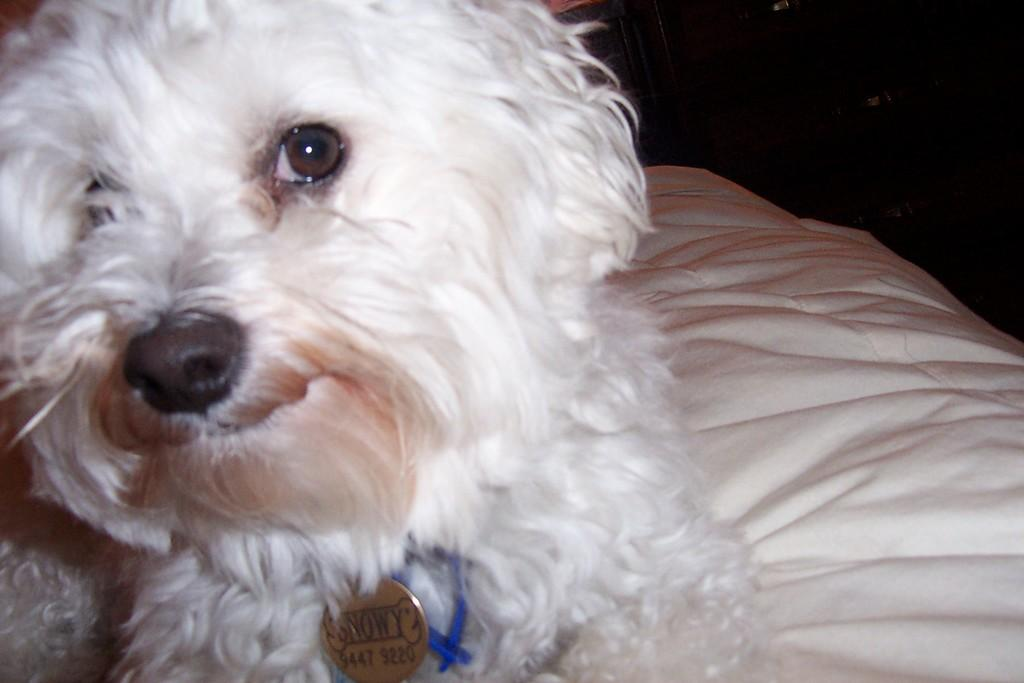What type of animal is in the image? There is a white color dog in the image. Where is the dog located? The dog is sitting on the bed. What color is the background of the image? The background of the image is black. What accessory can be seen in the image? There is a locket in the image. What is tied around the dog's neck? The dog has a blue color thread around its neck. What type of grass is the dog eating in the image? There is no grass present in the image, and the dog is not eating anything. 